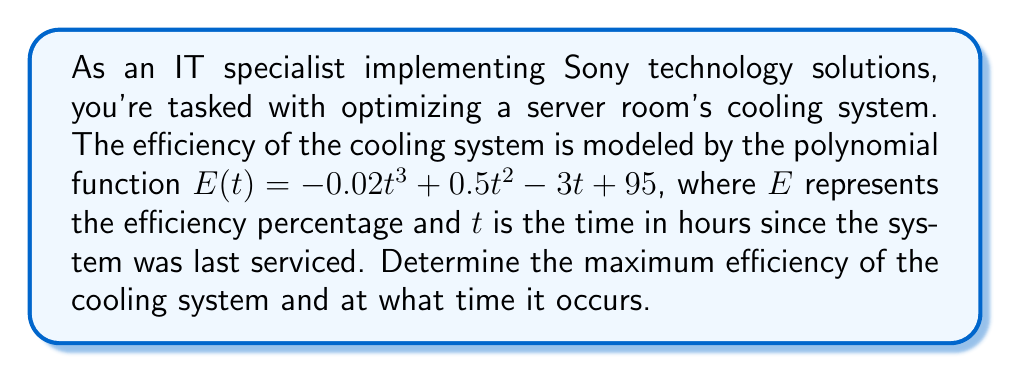Could you help me with this problem? To find the maximum efficiency of the cooling system, we need to find the maximum value of the function $E(t)$. This occurs at the point where the derivative of $E(t)$ is zero.

1. Find the derivative of $E(t)$:
   $$E'(t) = -0.06t^2 + t - 3$$

2. Set the derivative equal to zero and solve for t:
   $$-0.06t^2 + t - 3 = 0$$

3. This is a quadratic equation. We can solve it using the quadratic formula:
   $$t = \frac{-b \pm \sqrt{b^2 - 4ac}}{2a}$$
   where $a = -0.06$, $b = 1$, and $c = -3$

4. Substituting these values:
   $$t = \frac{-1 \pm \sqrt{1^2 - 4(-0.06)(-3)}}{2(-0.06)}$$
   $$t = \frac{-1 \pm \sqrt{1 - 0.72}}{-0.12}$$
   $$t = \frac{-1 \pm \sqrt{0.28}}{-0.12}$$
   $$t = \frac{-1 \pm 0.5291}{-0.12}$$

5. This gives us two solutions:
   $$t_1 = \frac{-1 - 0.5291}{-0.12} \approx 12.74$$
   $$t_2 = \frac{-1 + 0.5291}{-0.12} \approx 3.92$$

6. To determine which of these is the maximum (rather than the minimum), we can check the second derivative:
   $$E''(t) = -0.12t + 1$$
   At $t = 3.92$, $E''(3.92) = -0.12(3.92) + 1 = 0.5296 > 0$, indicating a local minimum.
   At $t = 12.74$, $E''(12.74) = -0.12(12.74) + 1 = -0.5288 < 0$, indicating a local maximum.

7. Therefore, the maximum efficiency occurs at $t \approx 3.92$ hours.

8. To find the maximum efficiency, substitute this value back into the original function:
   $$E(3.92) = -0.02(3.92)^3 + 0.5(3.92)^2 - 3(3.92) + 95 \approx 97.04$$
Answer: The maximum efficiency of the cooling system is approximately 97.04%, occurring about 3.92 hours after the system was last serviced. 